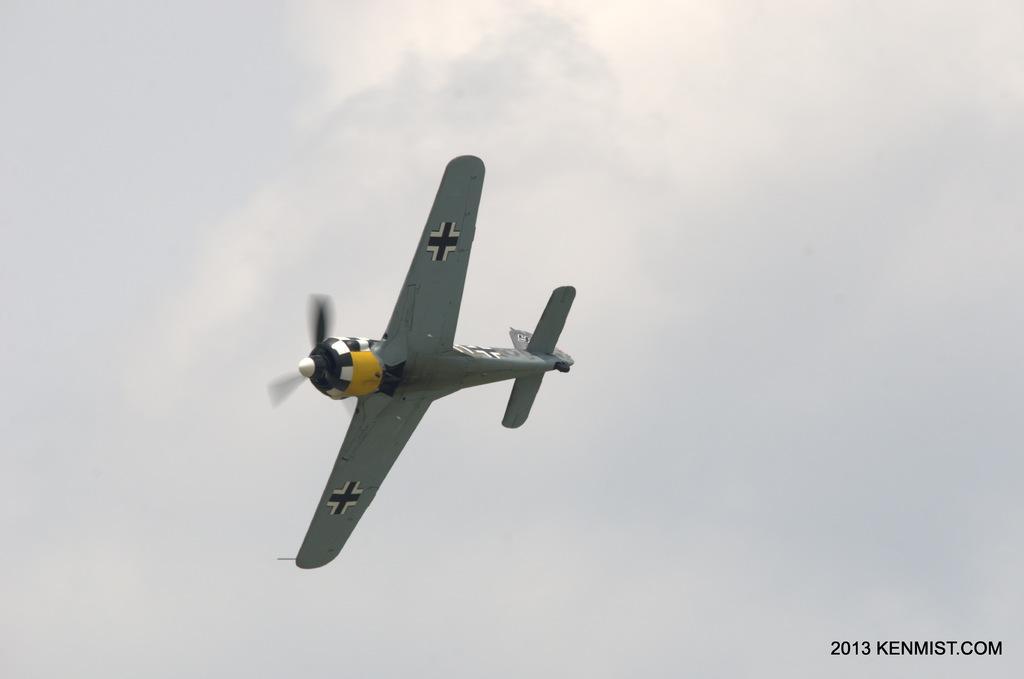Describe this image in one or two sentences. Here an aeroplane is flying in an air, it is in grey color. This is a cloudy sky. 